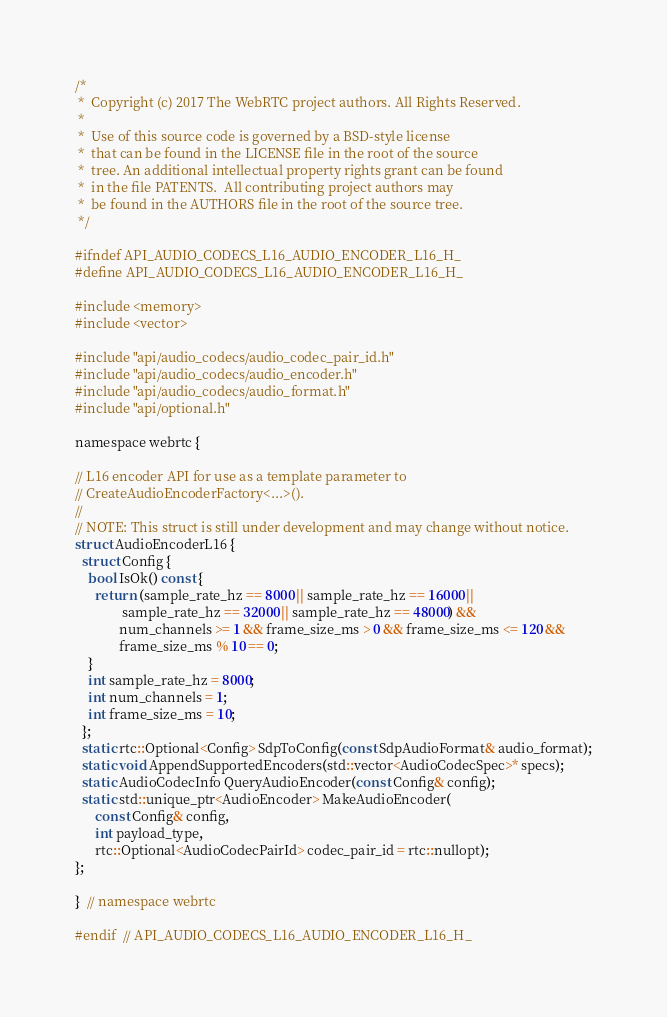<code> <loc_0><loc_0><loc_500><loc_500><_C_>/*
 *  Copyright (c) 2017 The WebRTC project authors. All Rights Reserved.
 *
 *  Use of this source code is governed by a BSD-style license
 *  that can be found in the LICENSE file in the root of the source
 *  tree. An additional intellectual property rights grant can be found
 *  in the file PATENTS.  All contributing project authors may
 *  be found in the AUTHORS file in the root of the source tree.
 */

#ifndef API_AUDIO_CODECS_L16_AUDIO_ENCODER_L16_H_
#define API_AUDIO_CODECS_L16_AUDIO_ENCODER_L16_H_

#include <memory>
#include <vector>

#include "api/audio_codecs/audio_codec_pair_id.h"
#include "api/audio_codecs/audio_encoder.h"
#include "api/audio_codecs/audio_format.h"
#include "api/optional.h"

namespace webrtc {

// L16 encoder API for use as a template parameter to
// CreateAudioEncoderFactory<...>().
//
// NOTE: This struct is still under development and may change without notice.
struct AudioEncoderL16 {
  struct Config {
    bool IsOk() const {
      return (sample_rate_hz == 8000 || sample_rate_hz == 16000 ||
              sample_rate_hz == 32000 || sample_rate_hz == 48000) &&
             num_channels >= 1 && frame_size_ms > 0 && frame_size_ms <= 120 &&
             frame_size_ms % 10 == 0;
    }
    int sample_rate_hz = 8000;
    int num_channels = 1;
    int frame_size_ms = 10;
  };
  static rtc::Optional<Config> SdpToConfig(const SdpAudioFormat& audio_format);
  static void AppendSupportedEncoders(std::vector<AudioCodecSpec>* specs);
  static AudioCodecInfo QueryAudioEncoder(const Config& config);
  static std::unique_ptr<AudioEncoder> MakeAudioEncoder(
      const Config& config,
      int payload_type,
      rtc::Optional<AudioCodecPairId> codec_pair_id = rtc::nullopt);
};

}  // namespace webrtc

#endif  // API_AUDIO_CODECS_L16_AUDIO_ENCODER_L16_H_
</code> 